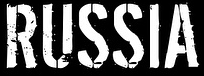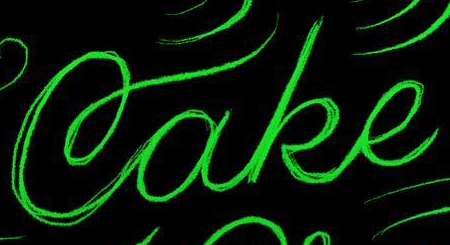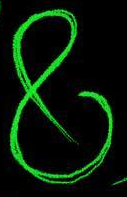What text appears in these images from left to right, separated by a semicolon? RUSSIA; Cake; & 